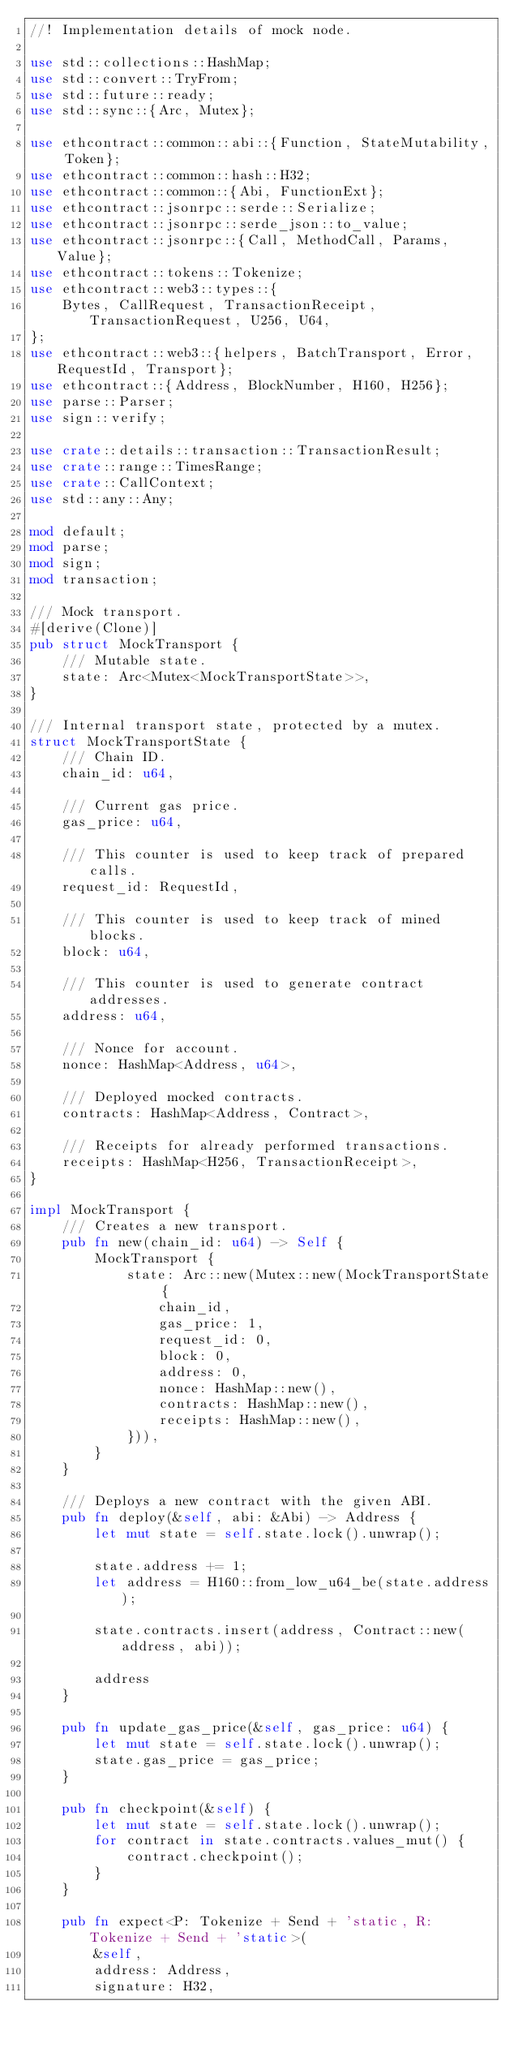Convert code to text. <code><loc_0><loc_0><loc_500><loc_500><_Rust_>//! Implementation details of mock node.

use std::collections::HashMap;
use std::convert::TryFrom;
use std::future::ready;
use std::sync::{Arc, Mutex};

use ethcontract::common::abi::{Function, StateMutability, Token};
use ethcontract::common::hash::H32;
use ethcontract::common::{Abi, FunctionExt};
use ethcontract::jsonrpc::serde::Serialize;
use ethcontract::jsonrpc::serde_json::to_value;
use ethcontract::jsonrpc::{Call, MethodCall, Params, Value};
use ethcontract::tokens::Tokenize;
use ethcontract::web3::types::{
    Bytes, CallRequest, TransactionReceipt, TransactionRequest, U256, U64,
};
use ethcontract::web3::{helpers, BatchTransport, Error, RequestId, Transport};
use ethcontract::{Address, BlockNumber, H160, H256};
use parse::Parser;
use sign::verify;

use crate::details::transaction::TransactionResult;
use crate::range::TimesRange;
use crate::CallContext;
use std::any::Any;

mod default;
mod parse;
mod sign;
mod transaction;

/// Mock transport.
#[derive(Clone)]
pub struct MockTransport {
    /// Mutable state.
    state: Arc<Mutex<MockTransportState>>,
}

/// Internal transport state, protected by a mutex.
struct MockTransportState {
    /// Chain ID.
    chain_id: u64,

    /// Current gas price.
    gas_price: u64,

    /// This counter is used to keep track of prepared calls.
    request_id: RequestId,

    /// This counter is used to keep track of mined blocks.
    block: u64,

    /// This counter is used to generate contract addresses.
    address: u64,

    /// Nonce for account.
    nonce: HashMap<Address, u64>,

    /// Deployed mocked contracts.
    contracts: HashMap<Address, Contract>,

    /// Receipts for already performed transactions.
    receipts: HashMap<H256, TransactionReceipt>,
}

impl MockTransport {
    /// Creates a new transport.
    pub fn new(chain_id: u64) -> Self {
        MockTransport {
            state: Arc::new(Mutex::new(MockTransportState {
                chain_id,
                gas_price: 1,
                request_id: 0,
                block: 0,
                address: 0,
                nonce: HashMap::new(),
                contracts: HashMap::new(),
                receipts: HashMap::new(),
            })),
        }
    }

    /// Deploys a new contract with the given ABI.
    pub fn deploy(&self, abi: &Abi) -> Address {
        let mut state = self.state.lock().unwrap();

        state.address += 1;
        let address = H160::from_low_u64_be(state.address);

        state.contracts.insert(address, Contract::new(address, abi));

        address
    }

    pub fn update_gas_price(&self, gas_price: u64) {
        let mut state = self.state.lock().unwrap();
        state.gas_price = gas_price;
    }

    pub fn checkpoint(&self) {
        let mut state = self.state.lock().unwrap();
        for contract in state.contracts.values_mut() {
            contract.checkpoint();
        }
    }

    pub fn expect<P: Tokenize + Send + 'static, R: Tokenize + Send + 'static>(
        &self,
        address: Address,
        signature: H32,</code> 